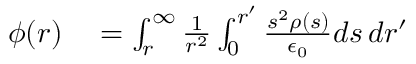Convert formula to latex. <formula><loc_0><loc_0><loc_500><loc_500>\begin{array} { r l } { \phi ( r ) } & = \int _ { r } ^ { \infty } \frac { 1 } { r ^ { 2 } } \int _ { 0 } ^ { r ^ { \prime } } \frac { s ^ { 2 } \rho ( s ) } { \epsilon _ { 0 } } d s \, d r ^ { \prime } } \end{array}</formula> 